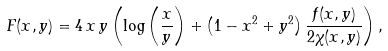Convert formula to latex. <formula><loc_0><loc_0><loc_500><loc_500>F ( x , y ) = 4 \, x \, y \left ( \log \left ( \frac { x } { y } \right ) + \left ( 1 - x ^ { 2 } + y ^ { 2 } \right ) \frac { f ( x , y ) } { 2 \chi ( x , y ) } \right ) ,</formula> 